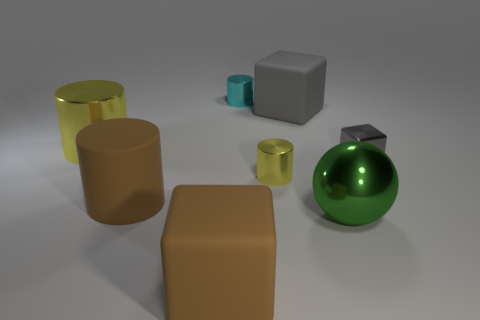What color is the large shiny thing on the right side of the large matte thing behind the gray metal block that is on the right side of the tiny yellow thing?
Make the answer very short. Green. What is the material of the tiny cyan object that is the same shape as the big yellow shiny object?
Keep it short and to the point. Metal. There is a yellow cylinder that is in front of the gray object in front of the gray matte object; how big is it?
Keep it short and to the point. Small. There is a big green object that is to the right of the big gray thing; what is it made of?
Offer a terse response. Metal. What size is the cyan thing that is the same material as the tiny gray cube?
Offer a very short reply. Small. How many gray metallic objects are the same shape as the cyan metallic object?
Offer a terse response. 0. There is a large gray object; is its shape the same as the big brown rubber object in front of the green thing?
Make the answer very short. Yes. What shape is the big thing that is the same color as the shiny cube?
Offer a very short reply. Cube. Are there any spheres made of the same material as the cyan cylinder?
Provide a succinct answer. Yes. What material is the large block that is on the left side of the big rubber thing that is behind the tiny gray cube?
Keep it short and to the point. Rubber. 